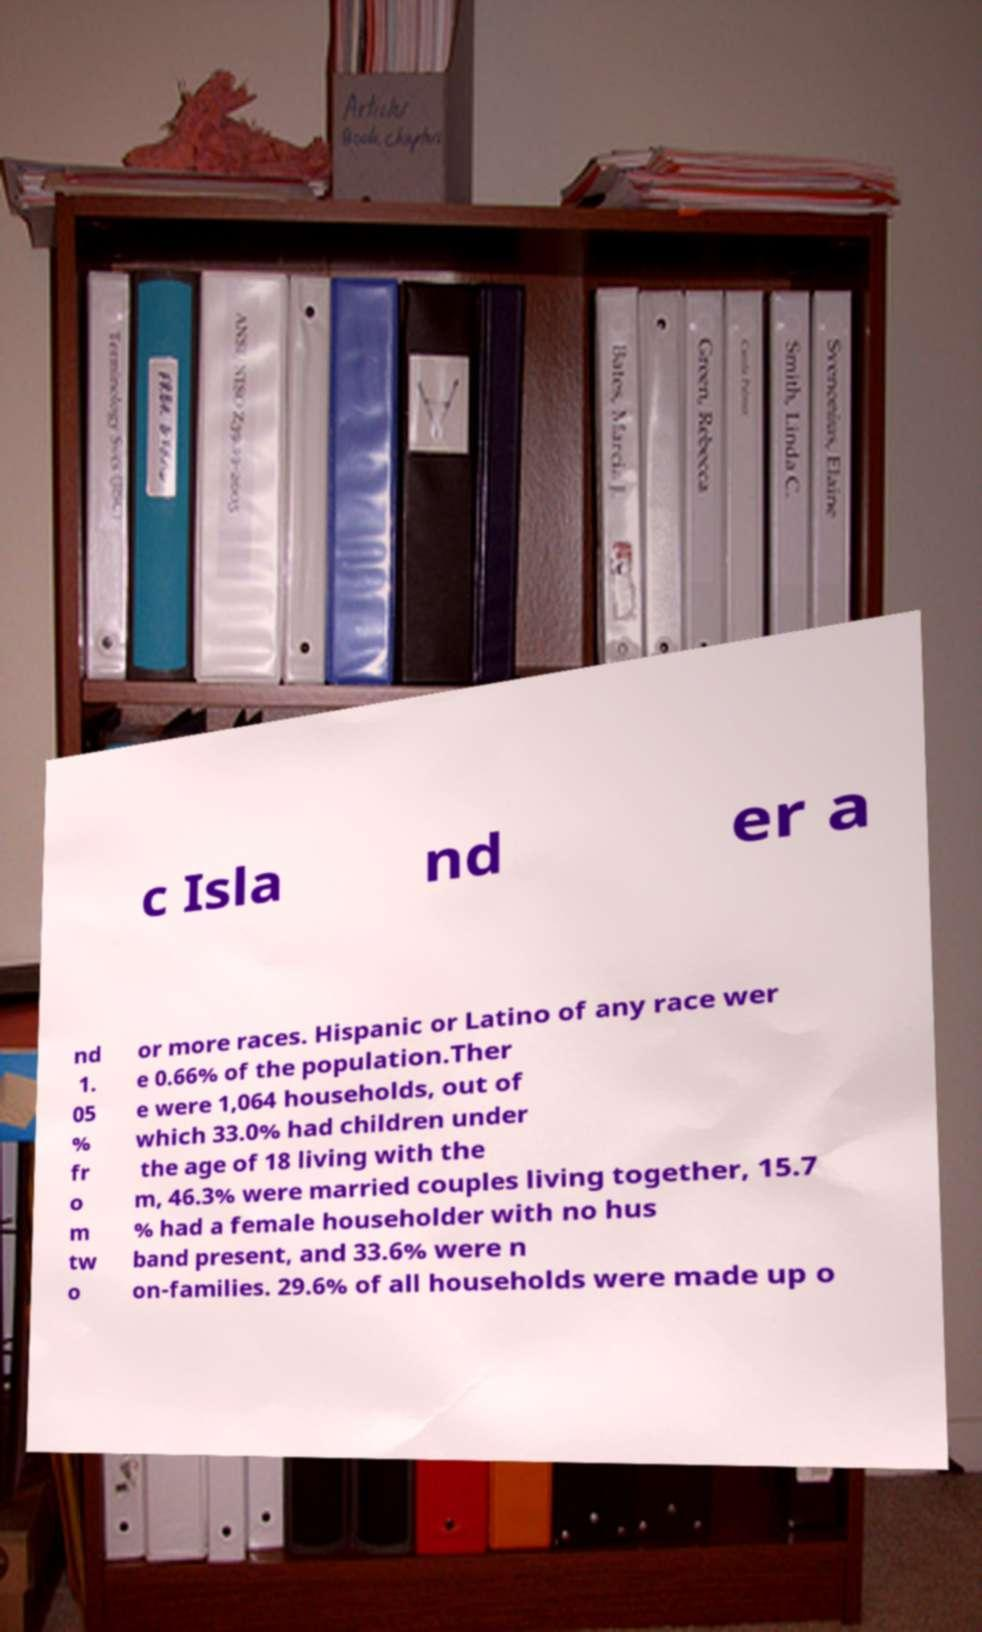Please read and relay the text visible in this image. What does it say? c Isla nd er a nd 1. 05 % fr o m tw o or more races. Hispanic or Latino of any race wer e 0.66% of the population.Ther e were 1,064 households, out of which 33.0% had children under the age of 18 living with the m, 46.3% were married couples living together, 15.7 % had a female householder with no hus band present, and 33.6% were n on-families. 29.6% of all households were made up o 